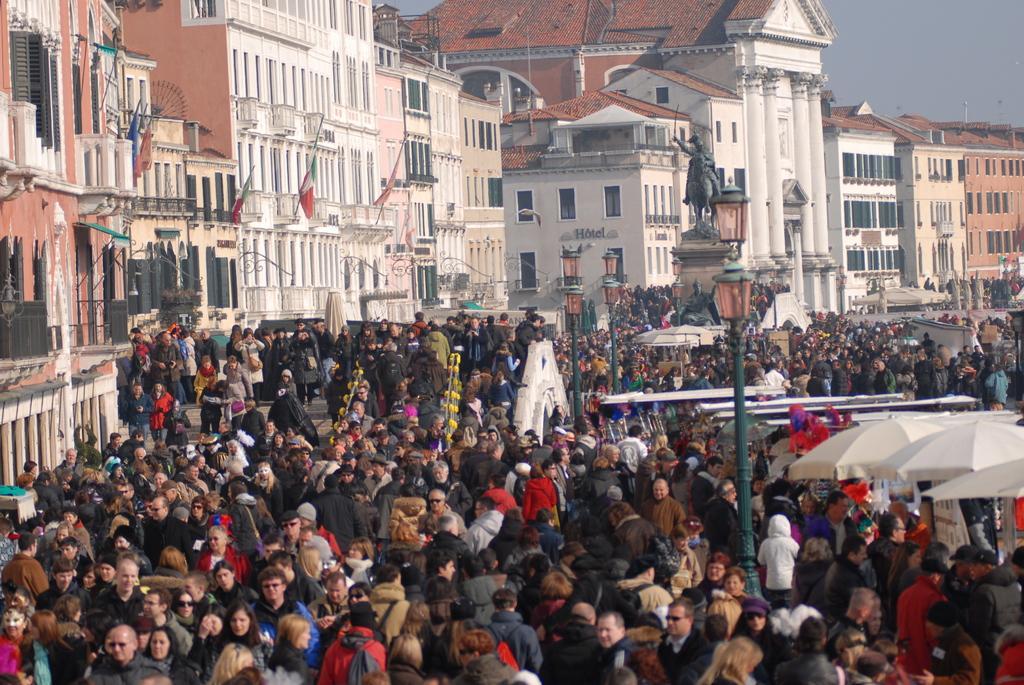How would you summarize this image in a sentence or two? In the image in the center,we can see group of people were standing. And we can see poles,tents etc. In the background we can see the sky,buildings,pillars,windows,flags,fences and statues. 